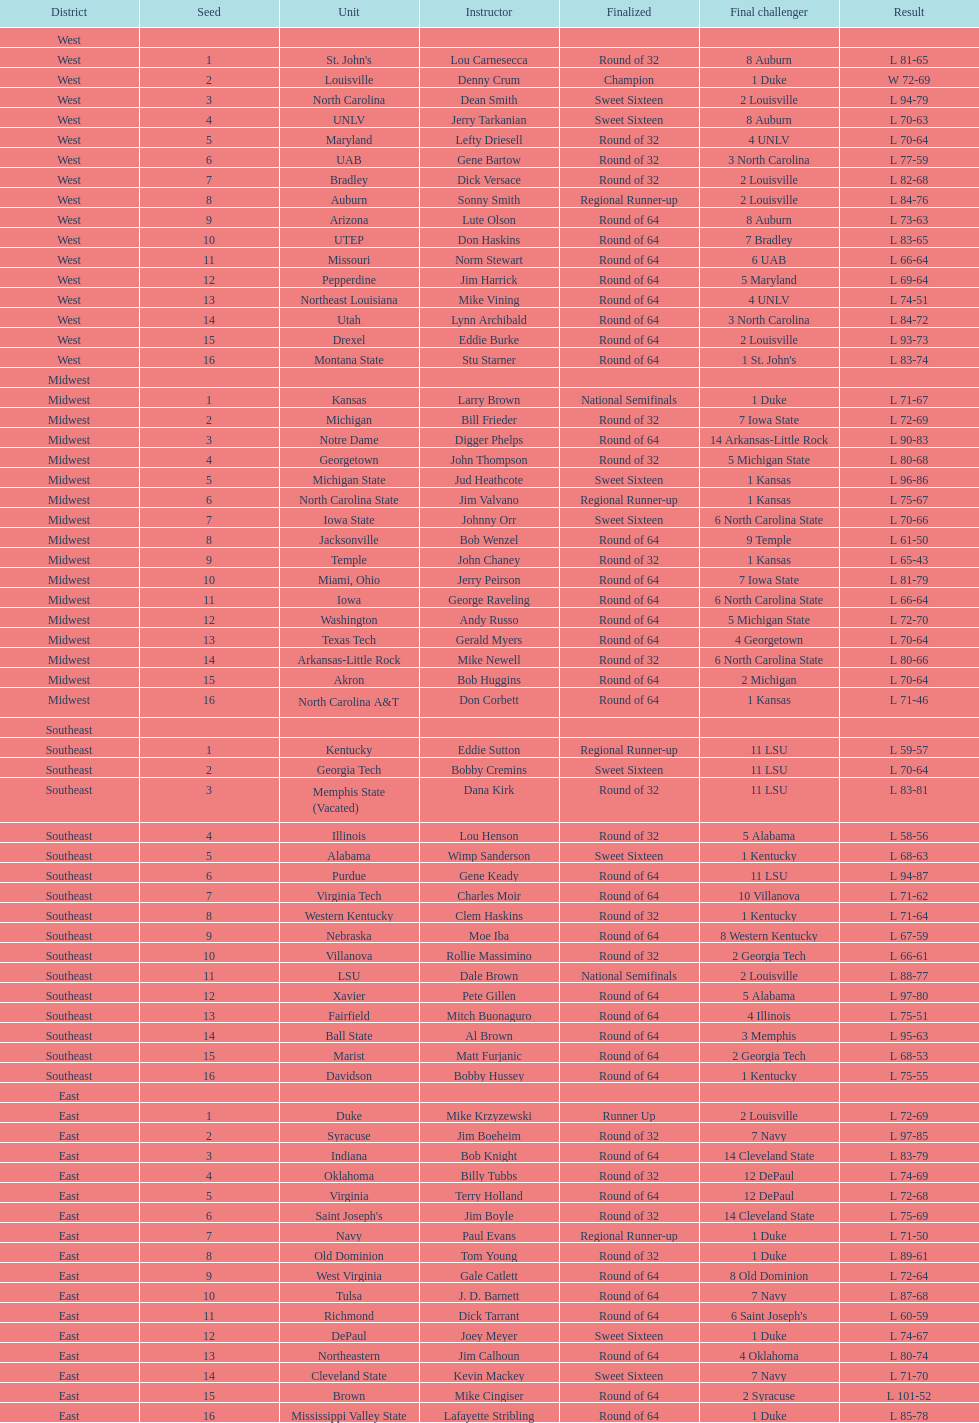Parse the table in full. {'header': ['District', 'Seed', 'Unit', 'Instructor', 'Finalized', 'Final challenger', 'Result'], 'rows': [['West', '', '', '', '', '', ''], ['West', '1', "St. John's", 'Lou Carnesecca', 'Round of 32', '8 Auburn', 'L 81-65'], ['West', '2', 'Louisville', 'Denny Crum', 'Champion', '1 Duke', 'W 72-69'], ['West', '3', 'North Carolina', 'Dean Smith', 'Sweet Sixteen', '2 Louisville', 'L 94-79'], ['West', '4', 'UNLV', 'Jerry Tarkanian', 'Sweet Sixteen', '8 Auburn', 'L 70-63'], ['West', '5', 'Maryland', 'Lefty Driesell', 'Round of 32', '4 UNLV', 'L 70-64'], ['West', '6', 'UAB', 'Gene Bartow', 'Round of 32', '3 North Carolina', 'L 77-59'], ['West', '7', 'Bradley', 'Dick Versace', 'Round of 32', '2 Louisville', 'L 82-68'], ['West', '8', 'Auburn', 'Sonny Smith', 'Regional Runner-up', '2 Louisville', 'L 84-76'], ['West', '9', 'Arizona', 'Lute Olson', 'Round of 64', '8 Auburn', 'L 73-63'], ['West', '10', 'UTEP', 'Don Haskins', 'Round of 64', '7 Bradley', 'L 83-65'], ['West', '11', 'Missouri', 'Norm Stewart', 'Round of 64', '6 UAB', 'L 66-64'], ['West', '12', 'Pepperdine', 'Jim Harrick', 'Round of 64', '5 Maryland', 'L 69-64'], ['West', '13', 'Northeast Louisiana', 'Mike Vining', 'Round of 64', '4 UNLV', 'L 74-51'], ['West', '14', 'Utah', 'Lynn Archibald', 'Round of 64', '3 North Carolina', 'L 84-72'], ['West', '15', 'Drexel', 'Eddie Burke', 'Round of 64', '2 Louisville', 'L 93-73'], ['West', '16', 'Montana State', 'Stu Starner', 'Round of 64', "1 St. John's", 'L 83-74'], ['Midwest', '', '', '', '', '', ''], ['Midwest', '1', 'Kansas', 'Larry Brown', 'National Semifinals', '1 Duke', 'L 71-67'], ['Midwest', '2', 'Michigan', 'Bill Frieder', 'Round of 32', '7 Iowa State', 'L 72-69'], ['Midwest', '3', 'Notre Dame', 'Digger Phelps', 'Round of 64', '14 Arkansas-Little Rock', 'L 90-83'], ['Midwest', '4', 'Georgetown', 'John Thompson', 'Round of 32', '5 Michigan State', 'L 80-68'], ['Midwest', '5', 'Michigan State', 'Jud Heathcote', 'Sweet Sixteen', '1 Kansas', 'L 96-86'], ['Midwest', '6', 'North Carolina State', 'Jim Valvano', 'Regional Runner-up', '1 Kansas', 'L 75-67'], ['Midwest', '7', 'Iowa State', 'Johnny Orr', 'Sweet Sixteen', '6 North Carolina State', 'L 70-66'], ['Midwest', '8', 'Jacksonville', 'Bob Wenzel', 'Round of 64', '9 Temple', 'L 61-50'], ['Midwest', '9', 'Temple', 'John Chaney', 'Round of 32', '1 Kansas', 'L 65-43'], ['Midwest', '10', 'Miami, Ohio', 'Jerry Peirson', 'Round of 64', '7 Iowa State', 'L 81-79'], ['Midwest', '11', 'Iowa', 'George Raveling', 'Round of 64', '6 North Carolina State', 'L 66-64'], ['Midwest', '12', 'Washington', 'Andy Russo', 'Round of 64', '5 Michigan State', 'L 72-70'], ['Midwest', '13', 'Texas Tech', 'Gerald Myers', 'Round of 64', '4 Georgetown', 'L 70-64'], ['Midwest', '14', 'Arkansas-Little Rock', 'Mike Newell', 'Round of 32', '6 North Carolina State', 'L 80-66'], ['Midwest', '15', 'Akron', 'Bob Huggins', 'Round of 64', '2 Michigan', 'L 70-64'], ['Midwest', '16', 'North Carolina A&T', 'Don Corbett', 'Round of 64', '1 Kansas', 'L 71-46'], ['Southeast', '', '', '', '', '', ''], ['Southeast', '1', 'Kentucky', 'Eddie Sutton', 'Regional Runner-up', '11 LSU', 'L 59-57'], ['Southeast', '2', 'Georgia Tech', 'Bobby Cremins', 'Sweet Sixteen', '11 LSU', 'L 70-64'], ['Southeast', '3', 'Memphis State (Vacated)', 'Dana Kirk', 'Round of 32', '11 LSU', 'L 83-81'], ['Southeast', '4', 'Illinois', 'Lou Henson', 'Round of 32', '5 Alabama', 'L 58-56'], ['Southeast', '5', 'Alabama', 'Wimp Sanderson', 'Sweet Sixteen', '1 Kentucky', 'L 68-63'], ['Southeast', '6', 'Purdue', 'Gene Keady', 'Round of 64', '11 LSU', 'L 94-87'], ['Southeast', '7', 'Virginia Tech', 'Charles Moir', 'Round of 64', '10 Villanova', 'L 71-62'], ['Southeast', '8', 'Western Kentucky', 'Clem Haskins', 'Round of 32', '1 Kentucky', 'L 71-64'], ['Southeast', '9', 'Nebraska', 'Moe Iba', 'Round of 64', '8 Western Kentucky', 'L 67-59'], ['Southeast', '10', 'Villanova', 'Rollie Massimino', 'Round of 32', '2 Georgia Tech', 'L 66-61'], ['Southeast', '11', 'LSU', 'Dale Brown', 'National Semifinals', '2 Louisville', 'L 88-77'], ['Southeast', '12', 'Xavier', 'Pete Gillen', 'Round of 64', '5 Alabama', 'L 97-80'], ['Southeast', '13', 'Fairfield', 'Mitch Buonaguro', 'Round of 64', '4 Illinois', 'L 75-51'], ['Southeast', '14', 'Ball State', 'Al Brown', 'Round of 64', '3 Memphis', 'L 95-63'], ['Southeast', '15', 'Marist', 'Matt Furjanic', 'Round of 64', '2 Georgia Tech', 'L 68-53'], ['Southeast', '16', 'Davidson', 'Bobby Hussey', 'Round of 64', '1 Kentucky', 'L 75-55'], ['East', '', '', '', '', '', ''], ['East', '1', 'Duke', 'Mike Krzyzewski', 'Runner Up', '2 Louisville', 'L 72-69'], ['East', '2', 'Syracuse', 'Jim Boeheim', 'Round of 32', '7 Navy', 'L 97-85'], ['East', '3', 'Indiana', 'Bob Knight', 'Round of 64', '14 Cleveland State', 'L 83-79'], ['East', '4', 'Oklahoma', 'Billy Tubbs', 'Round of 32', '12 DePaul', 'L 74-69'], ['East', '5', 'Virginia', 'Terry Holland', 'Round of 64', '12 DePaul', 'L 72-68'], ['East', '6', "Saint Joseph's", 'Jim Boyle', 'Round of 32', '14 Cleveland State', 'L 75-69'], ['East', '7', 'Navy', 'Paul Evans', 'Regional Runner-up', '1 Duke', 'L 71-50'], ['East', '8', 'Old Dominion', 'Tom Young', 'Round of 32', '1 Duke', 'L 89-61'], ['East', '9', 'West Virginia', 'Gale Catlett', 'Round of 64', '8 Old Dominion', 'L 72-64'], ['East', '10', 'Tulsa', 'J. D. Barnett', 'Round of 64', '7 Navy', 'L 87-68'], ['East', '11', 'Richmond', 'Dick Tarrant', 'Round of 64', "6 Saint Joseph's", 'L 60-59'], ['East', '12', 'DePaul', 'Joey Meyer', 'Sweet Sixteen', '1 Duke', 'L 74-67'], ['East', '13', 'Northeastern', 'Jim Calhoun', 'Round of 64', '4 Oklahoma', 'L 80-74'], ['East', '14', 'Cleveland State', 'Kevin Mackey', 'Sweet Sixteen', '7 Navy', 'L 71-70'], ['East', '15', 'Brown', 'Mike Cingiser', 'Round of 64', '2 Syracuse', 'L 101-52'], ['East', '16', 'Mississippi Valley State', 'Lafayette Stribling', 'Round of 64', '1 Duke', 'L 85-78']]} Which team went finished later in the tournament, st. john's or north carolina a&t? North Carolina A&T. 